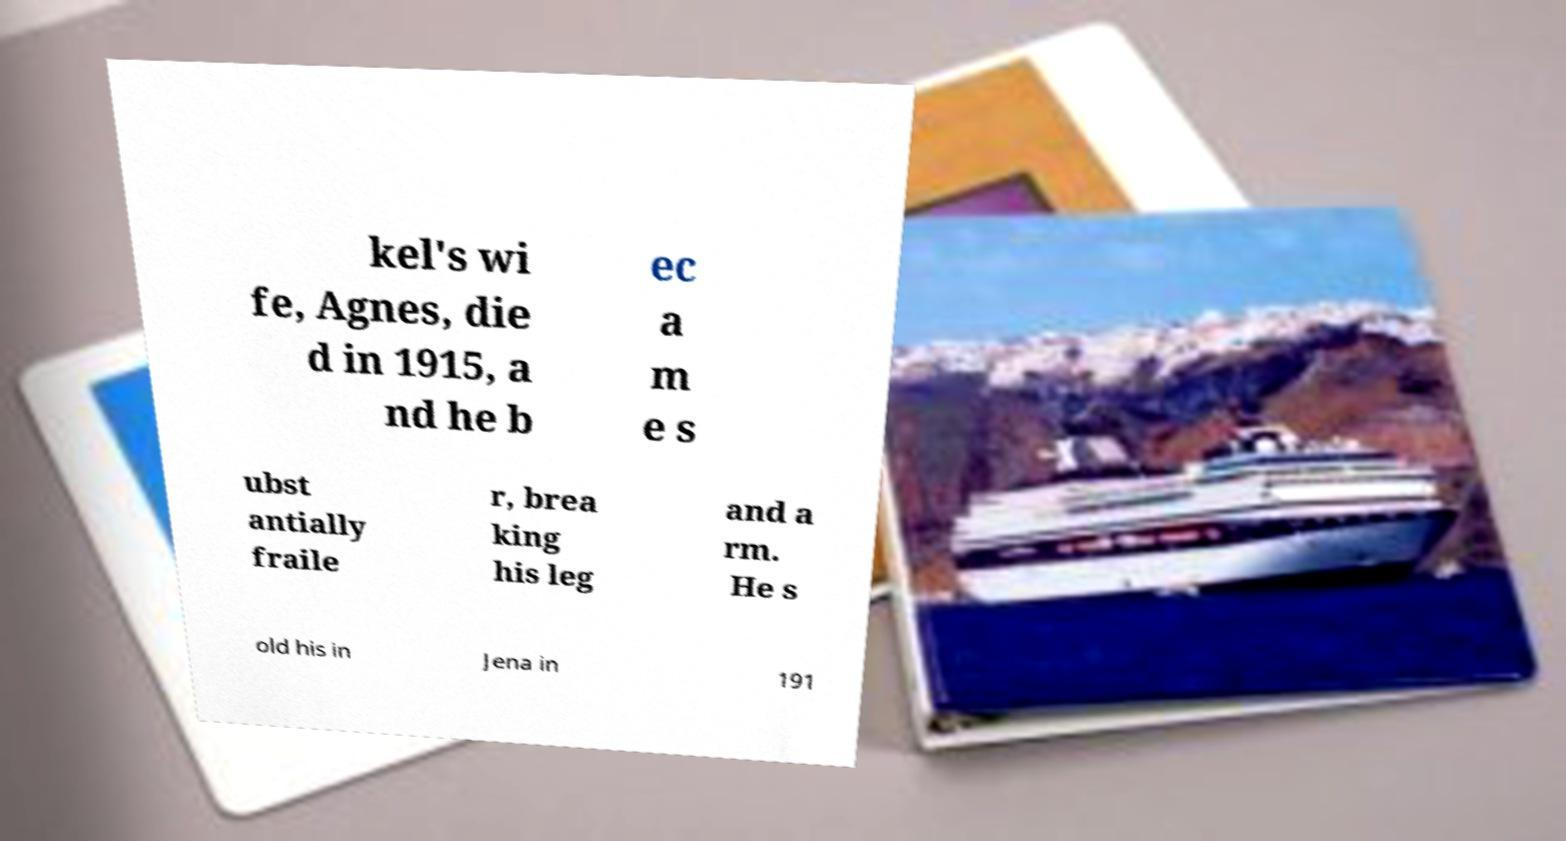Can you accurately transcribe the text from the provided image for me? kel's wi fe, Agnes, die d in 1915, a nd he b ec a m e s ubst antially fraile r, brea king his leg and a rm. He s old his in Jena in 191 